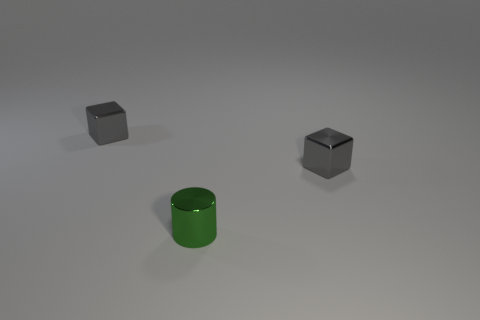How does the reflection on the green cylinder compare to the other objects? The reflection on the green cylinder is smoother and shows a higher level of shininess compared to the gray cubes, suggesting it has a more reflective surface. 